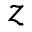<formula> <loc_0><loc_0><loc_500><loc_500>z</formula> 